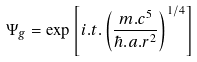<formula> <loc_0><loc_0><loc_500><loc_500>\Psi _ { g } = \exp \left [ i . t . \left ( { { \frac { { m . c ^ { 5 } } } { { \hbar { . } a . r ^ { 2 } } } } } \right ) ^ { 1 / 4 } \right ]</formula> 